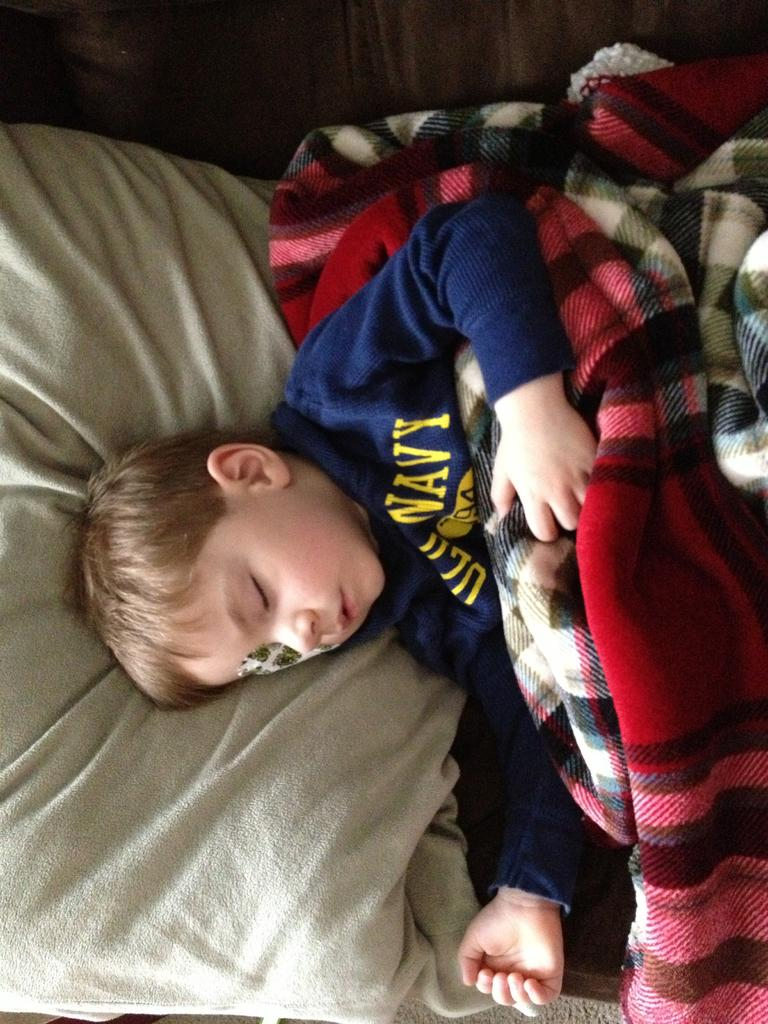Who is the main subject in the image? There is a boy in the image. What is covering the boy in the image? The boy has a blanket on him. What color is the sky in the image? There is no sky visible in the image; it only shows a boy with a blanket on him. 